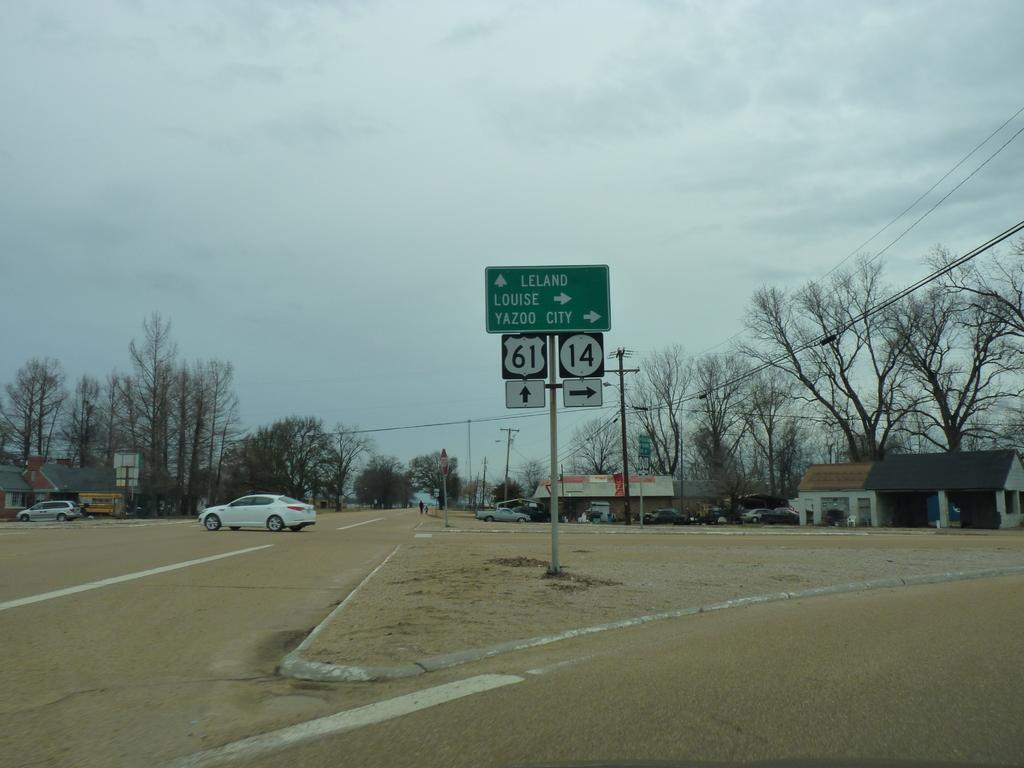Provide a one-sentence caption for the provided image. Road signs that point to Leland, Louise, or Yazoo City. 